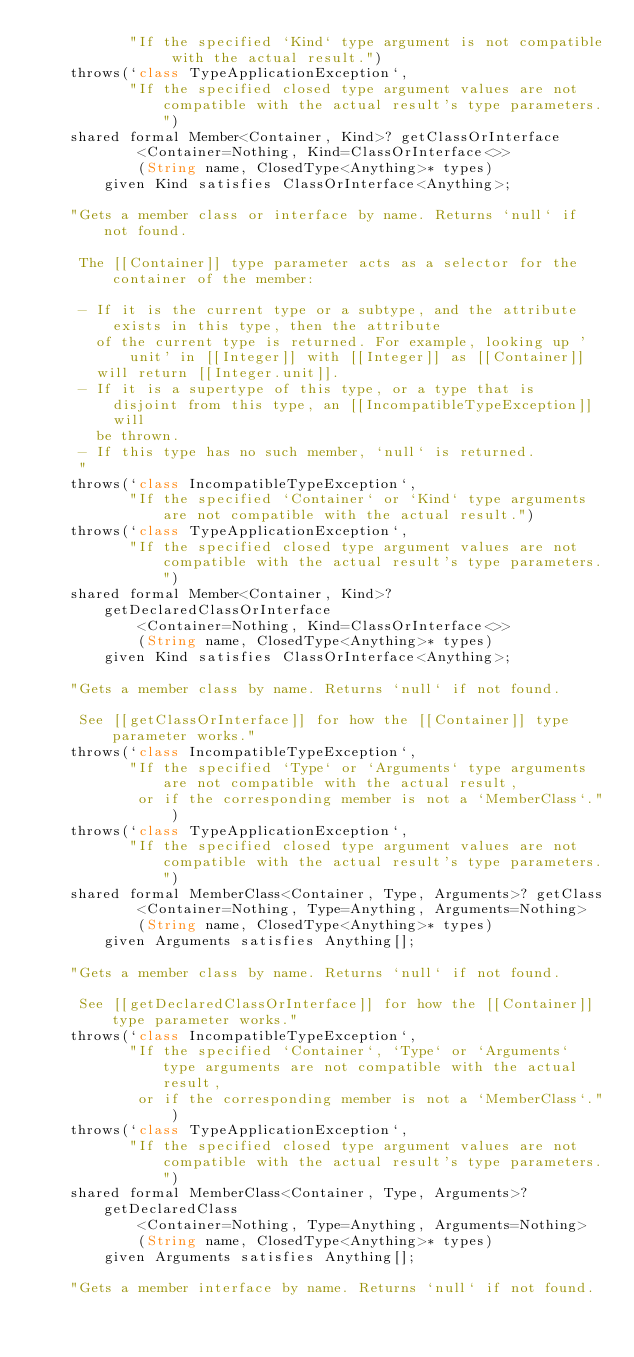Convert code to text. <code><loc_0><loc_0><loc_500><loc_500><_Ceylon_>           "If the specified `Kind` type argument is not compatible with the actual result.")
    throws(`class TypeApplicationException`, 
           "If the specified closed type argument values are not compatible with the actual result's type parameters.")
    shared formal Member<Container, Kind>? getClassOrInterface
            <Container=Nothing, Kind=ClassOrInterface<>>
            (String name, ClosedType<Anything>* types)
        given Kind satisfies ClassOrInterface<Anything>;

    "Gets a member class or interface by name. Returns `null` if not found.
     
     The [[Container]] type parameter acts as a selector for the container of the member:
     
     - If it is the current type or a subtype, and the attribute exists in this type, then the attribute
       of the current type is returned. For example, looking up 'unit' in [[Integer]] with [[Integer]] as [[Container]]
       will return [[Integer.unit]].
     - If it is a supertype of this type, or a type that is disjoint from this type, an [[IncompatibleTypeException]] will
       be thrown.
     - If this type has no such member, `null` is returned.
     "
    throws(`class IncompatibleTypeException`, 
           "If the specified `Container` or `Kind` type arguments are not compatible with the actual result.")
    throws(`class TypeApplicationException`, 
           "If the specified closed type argument values are not compatible with the actual result's type parameters.")
    shared formal Member<Container, Kind>? getDeclaredClassOrInterface
            <Container=Nothing, Kind=ClassOrInterface<>>
            (String name, ClosedType<Anything>* types)
        given Kind satisfies ClassOrInterface<Anything>;

    "Gets a member class by name. Returns `null` if not found.
     
     See [[getClassOrInterface]] for how the [[Container]] type parameter works."
    throws(`class IncompatibleTypeException`, 
           "If the specified `Type` or `Arguments` type arguments are not compatible with the actual result, 
            or if the corresponding member is not a `MemberClass`.")
    throws(`class TypeApplicationException`, 
           "If the specified closed type argument values are not compatible with the actual result's type parameters.")
    shared formal MemberClass<Container, Type, Arguments>? getClass
            <Container=Nothing, Type=Anything, Arguments=Nothing>
            (String name, ClosedType<Anything>* types)
        given Arguments satisfies Anything[];

    "Gets a member class by name. Returns `null` if not found.
     
     See [[getDeclaredClassOrInterface]] for how the [[Container]] type parameter works."
    throws(`class IncompatibleTypeException`, 
           "If the specified `Container`, `Type` or `Arguments` type arguments are not compatible with the actual result, 
            or if the corresponding member is not a `MemberClass`.")
    throws(`class TypeApplicationException`, 
           "If the specified closed type argument values are not compatible with the actual result's type parameters.")
    shared formal MemberClass<Container, Type, Arguments>? getDeclaredClass
            <Container=Nothing, Type=Anything, Arguments=Nothing>
            (String name, ClosedType<Anything>* types)
        given Arguments satisfies Anything[];

    "Gets a member interface by name. Returns `null` if not found.
     </code> 